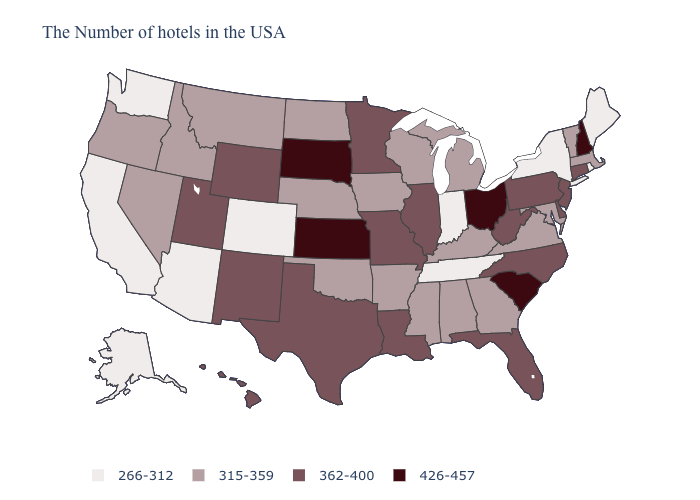Which states have the lowest value in the Northeast?
Be succinct. Maine, Rhode Island, New York. Does Indiana have the same value as Maine?
Give a very brief answer. Yes. What is the highest value in the MidWest ?
Give a very brief answer. 426-457. What is the highest value in the USA?
Answer briefly. 426-457. What is the value of Idaho?
Quick response, please. 315-359. Does the first symbol in the legend represent the smallest category?
Answer briefly. Yes. Name the states that have a value in the range 426-457?
Concise answer only. New Hampshire, South Carolina, Ohio, Kansas, South Dakota. Name the states that have a value in the range 426-457?
Keep it brief. New Hampshire, South Carolina, Ohio, Kansas, South Dakota. What is the highest value in the West ?
Be succinct. 362-400. Which states hav the highest value in the MidWest?
Short answer required. Ohio, Kansas, South Dakota. Name the states that have a value in the range 315-359?
Be succinct. Massachusetts, Vermont, Maryland, Virginia, Georgia, Michigan, Kentucky, Alabama, Wisconsin, Mississippi, Arkansas, Iowa, Nebraska, Oklahoma, North Dakota, Montana, Idaho, Nevada, Oregon. Which states hav the highest value in the Northeast?
Answer briefly. New Hampshire. What is the highest value in the West ?
Short answer required. 362-400. What is the lowest value in the Northeast?
Write a very short answer. 266-312. Does the first symbol in the legend represent the smallest category?
Quick response, please. Yes. 